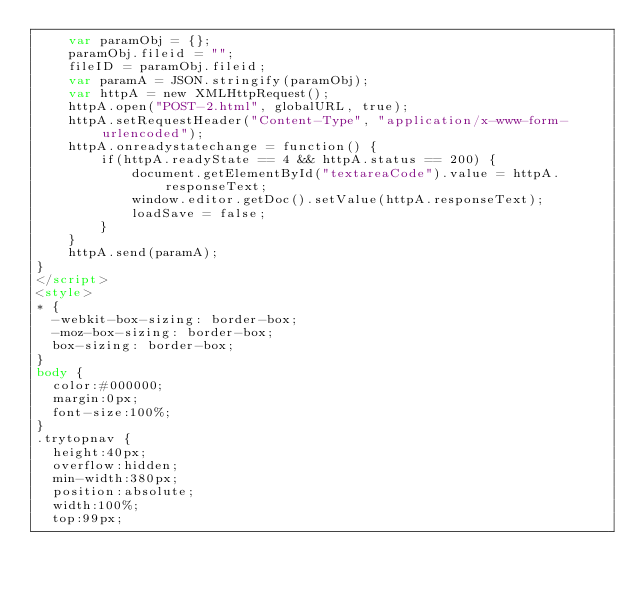Convert code to text. <code><loc_0><loc_0><loc_500><loc_500><_HTML_>    var paramObj = {};
    paramObj.fileid = "";
    fileID = paramObj.fileid;
    var paramA = JSON.stringify(paramObj);
    var httpA = new XMLHttpRequest();
    httpA.open("POST-2.html", globalURL, true);
    httpA.setRequestHeader("Content-Type", "application/x-www-form-urlencoded");
    httpA.onreadystatechange = function() {
        if(httpA.readyState == 4 && httpA.status == 200) {
            document.getElementById("textareaCode").value = httpA.responseText;
            window.editor.getDoc().setValue(httpA.responseText);
            loadSave = false;
        }
    }
    httpA.send(paramA);   
}
</script>
<style>
* {
  -webkit-box-sizing: border-box;
  -moz-box-sizing: border-box;
  box-sizing: border-box;
}
body {
  color:#000000;
  margin:0px;
  font-size:100%;
}
.trytopnav {
  height:40px;
  overflow:hidden;
  min-width:380px;
  position:absolute;
  width:100%;
  top:99px;
</code> 